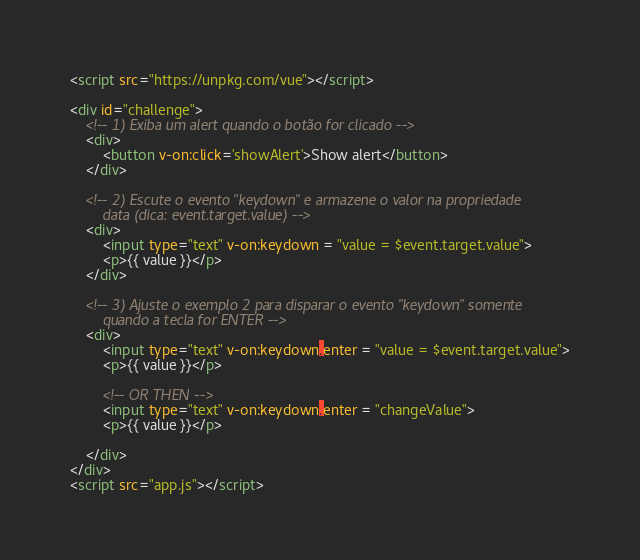Convert code to text. <code><loc_0><loc_0><loc_500><loc_500><_HTML_><script src="https://unpkg.com/vue"></script>

<div id="challenge">
    <!-- 1) Exiba um alert quando o botão for clicado -->
    <div>
        <button v-on:click='showAlert'>Show alert</button>
    </div>
    
    <!-- 2) Escute o evento "keydown" e armazene o valor na propriedade
        data (dica: event.target.value) -->
    <div>
        <input type="text" v-on:keydown = "value = $event.target.value">
        <p>{{ value }}</p>
    </div>
    
    <!-- 3) Ajuste o exemplo 2 para disparar o evento "keydown" somente
        quando a tecla for ENTER -->
    <div>
        <input type="text" v-on:keydown.enter = "value = $event.target.value">
        <p>{{ value }}</p>

        <!-- OR THEN -->
        <input type="text" v-on:keydown.enter = "changeValue">
        <p>{{ value }}</p>

    </div>
</div>
<script src="app.js"></script></code> 